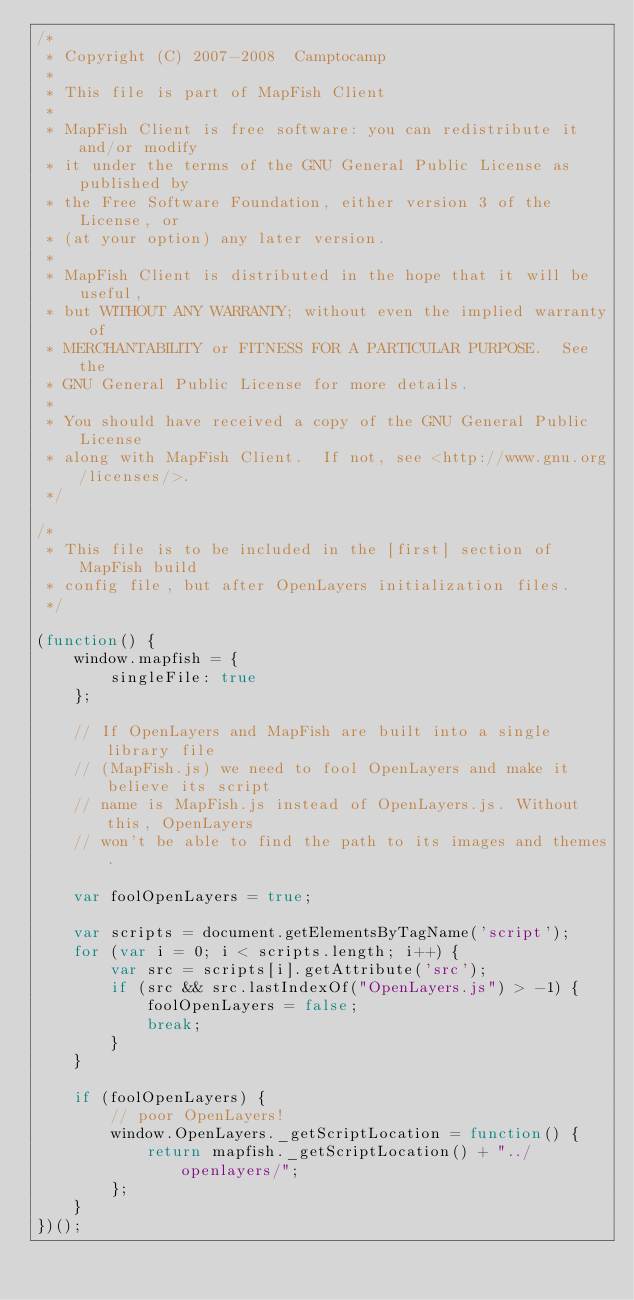<code> <loc_0><loc_0><loc_500><loc_500><_JavaScript_>/*
 * Copyright (C) 2007-2008  Camptocamp
 *
 * This file is part of MapFish Client
 *
 * MapFish Client is free software: you can redistribute it and/or modify
 * it under the terms of the GNU General Public License as published by
 * the Free Software Foundation, either version 3 of the License, or
 * (at your option) any later version.
 *
 * MapFish Client is distributed in the hope that it will be useful,
 * but WITHOUT ANY WARRANTY; without even the implied warranty of
 * MERCHANTABILITY or FITNESS FOR A PARTICULAR PURPOSE.  See the
 * GNU General Public License for more details.
 *
 * You should have received a copy of the GNU General Public License
 * along with MapFish Client.  If not, see <http://www.gnu.org/licenses/>.
 */

/*
 * This file is to be included in the [first] section of MapFish build
 * config file, but after OpenLayers initialization files.
 */

(function() {
    window.mapfish = {
        singleFile: true
    };

    // If OpenLayers and MapFish are built into a single library file
    // (MapFish.js) we need to fool OpenLayers and make it believe its script
    // name is MapFish.js instead of OpenLayers.js. Without this, OpenLayers
    // won't be able to find the path to its images and themes.

    var foolOpenLayers = true;
    
    var scripts = document.getElementsByTagName('script');
    for (var i = 0; i < scripts.length; i++) {
        var src = scripts[i].getAttribute('src');
        if (src && src.lastIndexOf("OpenLayers.js") > -1) {
            foolOpenLayers = false;
            break;
        }
    }

    if (foolOpenLayers) {
        // poor OpenLayers!
        window.OpenLayers._getScriptLocation = function() {
            return mapfish._getScriptLocation() + "../openlayers/";
        };
    }
})();
</code> 